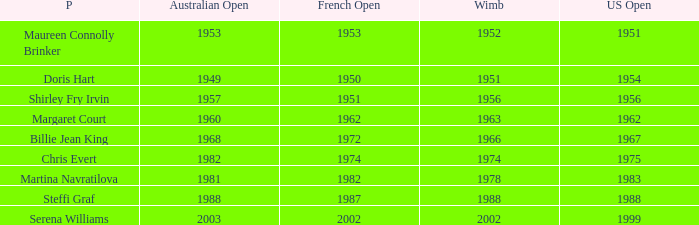When did Shirley Fry Irvin win the US Open? 1956.0. 